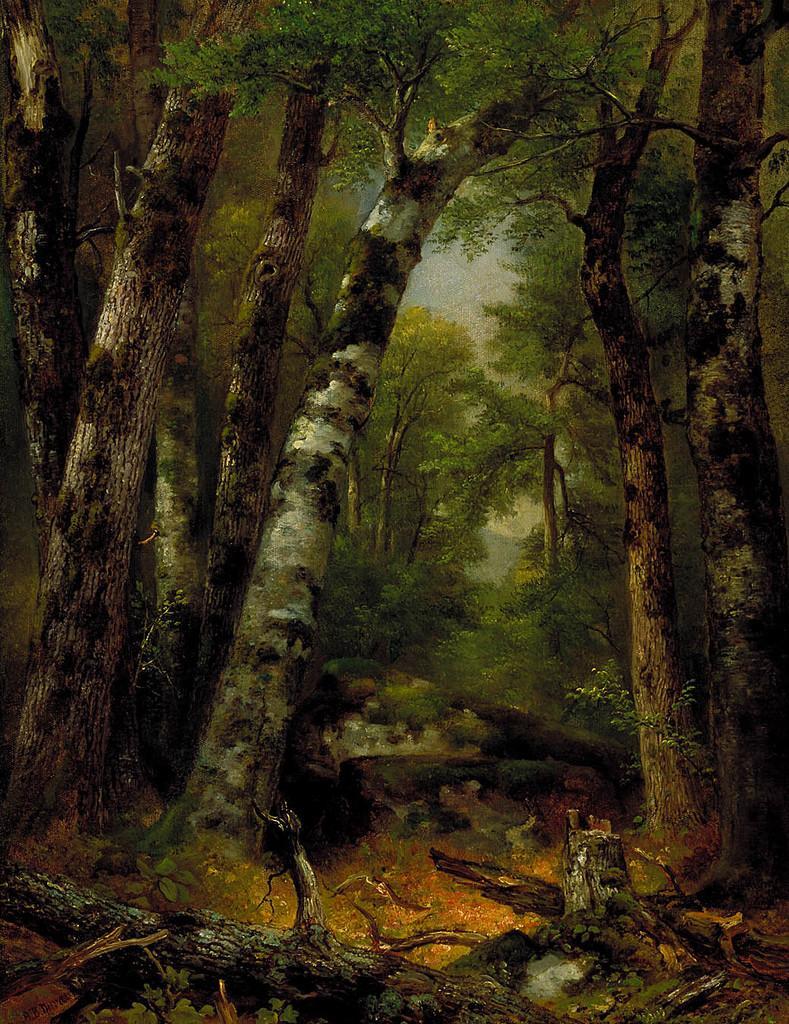Could you give a brief overview of what you see in this image? This image is graphical image where there are trees and there are tree branches on the ground. 